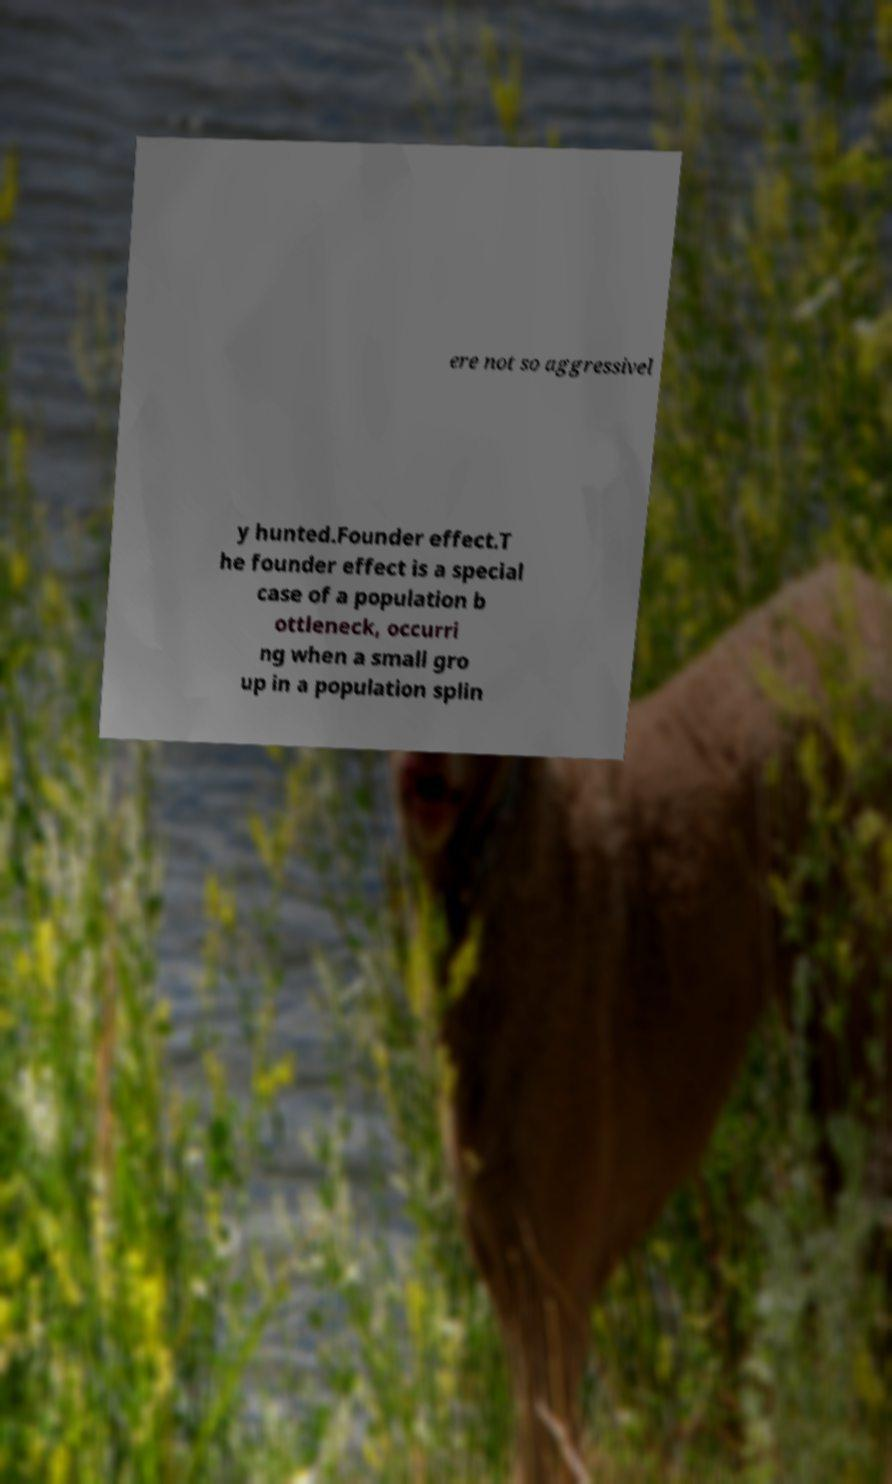There's text embedded in this image that I need extracted. Can you transcribe it verbatim? ere not so aggressivel y hunted.Founder effect.T he founder effect is a special case of a population b ottleneck, occurri ng when a small gro up in a population splin 